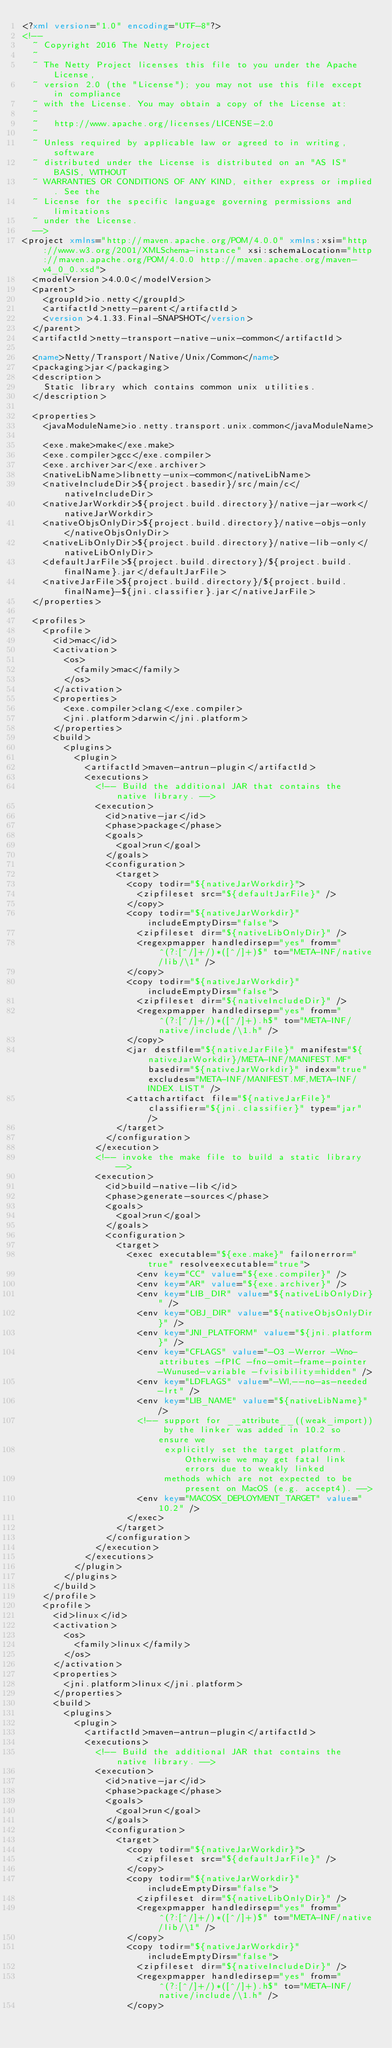Convert code to text. <code><loc_0><loc_0><loc_500><loc_500><_XML_><?xml version="1.0" encoding="UTF-8"?>
<!--
  ~ Copyright 2016 The Netty Project
  ~
  ~ The Netty Project licenses this file to you under the Apache License,
  ~ version 2.0 (the "License"); you may not use this file except in compliance
  ~ with the License. You may obtain a copy of the License at:
  ~
  ~   http://www.apache.org/licenses/LICENSE-2.0
  ~
  ~ Unless required by applicable law or agreed to in writing, software
  ~ distributed under the License is distributed on an "AS IS" BASIS, WITHOUT
  ~ WARRANTIES OR CONDITIONS OF ANY KIND, either express or implied. See the
  ~ License for the specific language governing permissions and limitations
  ~ under the License.
  -->
<project xmlns="http://maven.apache.org/POM/4.0.0" xmlns:xsi="http://www.w3.org/2001/XMLSchema-instance" xsi:schemaLocation="http://maven.apache.org/POM/4.0.0 http://maven.apache.org/maven-v4_0_0.xsd">
  <modelVersion>4.0.0</modelVersion>
  <parent>
    <groupId>io.netty</groupId>
    <artifactId>netty-parent</artifactId>
    <version>4.1.33.Final-SNAPSHOT</version>
  </parent>
  <artifactId>netty-transport-native-unix-common</artifactId>

  <name>Netty/Transport/Native/Unix/Common</name>
  <packaging>jar</packaging>
  <description>
    Static library which contains common unix utilities.
  </description>

  <properties>
    <javaModuleName>io.netty.transport.unix.common</javaModuleName>

    <exe.make>make</exe.make>
    <exe.compiler>gcc</exe.compiler>
    <exe.archiver>ar</exe.archiver>
    <nativeLibName>libnetty-unix-common</nativeLibName>
    <nativeIncludeDir>${project.basedir}/src/main/c</nativeIncludeDir>
    <nativeJarWorkdir>${project.build.directory}/native-jar-work</nativeJarWorkdir>
    <nativeObjsOnlyDir>${project.build.directory}/native-objs-only</nativeObjsOnlyDir>
    <nativeLibOnlyDir>${project.build.directory}/native-lib-only</nativeLibOnlyDir>
    <defaultJarFile>${project.build.directory}/${project.build.finalName}.jar</defaultJarFile>
    <nativeJarFile>${project.build.directory}/${project.build.finalName}-${jni.classifier}.jar</nativeJarFile>
  </properties>

  <profiles>
    <profile>
      <id>mac</id>
      <activation>
        <os>
          <family>mac</family>
        </os>
      </activation>
      <properties>
        <exe.compiler>clang</exe.compiler>
        <jni.platform>darwin</jni.platform>
      </properties>
      <build>
        <plugins>
          <plugin>
            <artifactId>maven-antrun-plugin</artifactId>
            <executions>
              <!-- Build the additional JAR that contains the native library. -->
              <execution>
                <id>native-jar</id>
                <phase>package</phase>
                <goals>
                  <goal>run</goal>
                </goals>
                <configuration>
                  <target>
                    <copy todir="${nativeJarWorkdir}">
                      <zipfileset src="${defaultJarFile}" />
                    </copy>
                    <copy todir="${nativeJarWorkdir}" includeEmptyDirs="false">
                      <zipfileset dir="${nativeLibOnlyDir}" />
                      <regexpmapper handledirsep="yes" from="^(?:[^/]+/)*([^/]+)$" to="META-INF/native/lib/\1" />
                    </copy>
                    <copy todir="${nativeJarWorkdir}" includeEmptyDirs="false">
                      <zipfileset dir="${nativeIncludeDir}" />
                      <regexpmapper handledirsep="yes" from="^(?:[^/]+/)*([^/]+).h$" to="META-INF/native/include/\1.h" />
                    </copy>
                    <jar destfile="${nativeJarFile}" manifest="${nativeJarWorkdir}/META-INF/MANIFEST.MF" basedir="${nativeJarWorkdir}" index="true" excludes="META-INF/MANIFEST.MF,META-INF/INDEX.LIST" />
                    <attachartifact file="${nativeJarFile}" classifier="${jni.classifier}" type="jar" />
                  </target>
                </configuration>
              </execution>
              <!-- invoke the make file to build a static library -->
              <execution>
                <id>build-native-lib</id>
                <phase>generate-sources</phase>
                <goals>
                  <goal>run</goal>
                </goals>
                <configuration>
                  <target>
                    <exec executable="${exe.make}" failonerror="true" resolveexecutable="true">
                      <env key="CC" value="${exe.compiler}" />
                      <env key="AR" value="${exe.archiver}" />
                      <env key="LIB_DIR" value="${nativeLibOnlyDir}" />
                      <env key="OBJ_DIR" value="${nativeObjsOnlyDir}" />
                      <env key="JNI_PLATFORM" value="${jni.platform}" />
                      <env key="CFLAGS" value="-O3 -Werror -Wno-attributes -fPIC -fno-omit-frame-pointer -Wunused-variable -fvisibility=hidden" />
                      <env key="LDFLAGS" value="-Wl,--no-as-needed -lrt" />
                      <env key="LIB_NAME" value="${nativeLibName}" />
                      <!-- support for __attribute__((weak_import)) by the linker was added in 10.2 so ensure we
                           explicitly set the target platform. Otherwise we may get fatal link errors due to weakly linked
                           methods which are not expected to be present on MacOS (e.g. accept4). -->
                      <env key="MACOSX_DEPLOYMENT_TARGET" value="10.2" />
                    </exec>
                  </target>
                </configuration>
              </execution>
            </executions>
          </plugin>
        </plugins>
      </build>
    </profile>
    <profile>
      <id>linux</id>
      <activation>
        <os>
          <family>linux</family>
        </os>
      </activation>
      <properties>
        <jni.platform>linux</jni.platform>
      </properties>
      <build>
        <plugins>
          <plugin>
            <artifactId>maven-antrun-plugin</artifactId>
            <executions>
              <!-- Build the additional JAR that contains the native library. -->
              <execution>
                <id>native-jar</id>
                <phase>package</phase>
                <goals>
                  <goal>run</goal>
                </goals>
                <configuration>
                  <target>
                    <copy todir="${nativeJarWorkdir}">
                      <zipfileset src="${defaultJarFile}" />
                    </copy>
                    <copy todir="${nativeJarWorkdir}" includeEmptyDirs="false">
                      <zipfileset dir="${nativeLibOnlyDir}" />
                      <regexpmapper handledirsep="yes" from="^(?:[^/]+/)*([^/]+)$" to="META-INF/native/lib/\1" />
                    </copy>
                    <copy todir="${nativeJarWorkdir}" includeEmptyDirs="false">
                      <zipfileset dir="${nativeIncludeDir}" />
                      <regexpmapper handledirsep="yes" from="^(?:[^/]+/)*([^/]+).h$" to="META-INF/native/include/\1.h" />
                    </copy></code> 